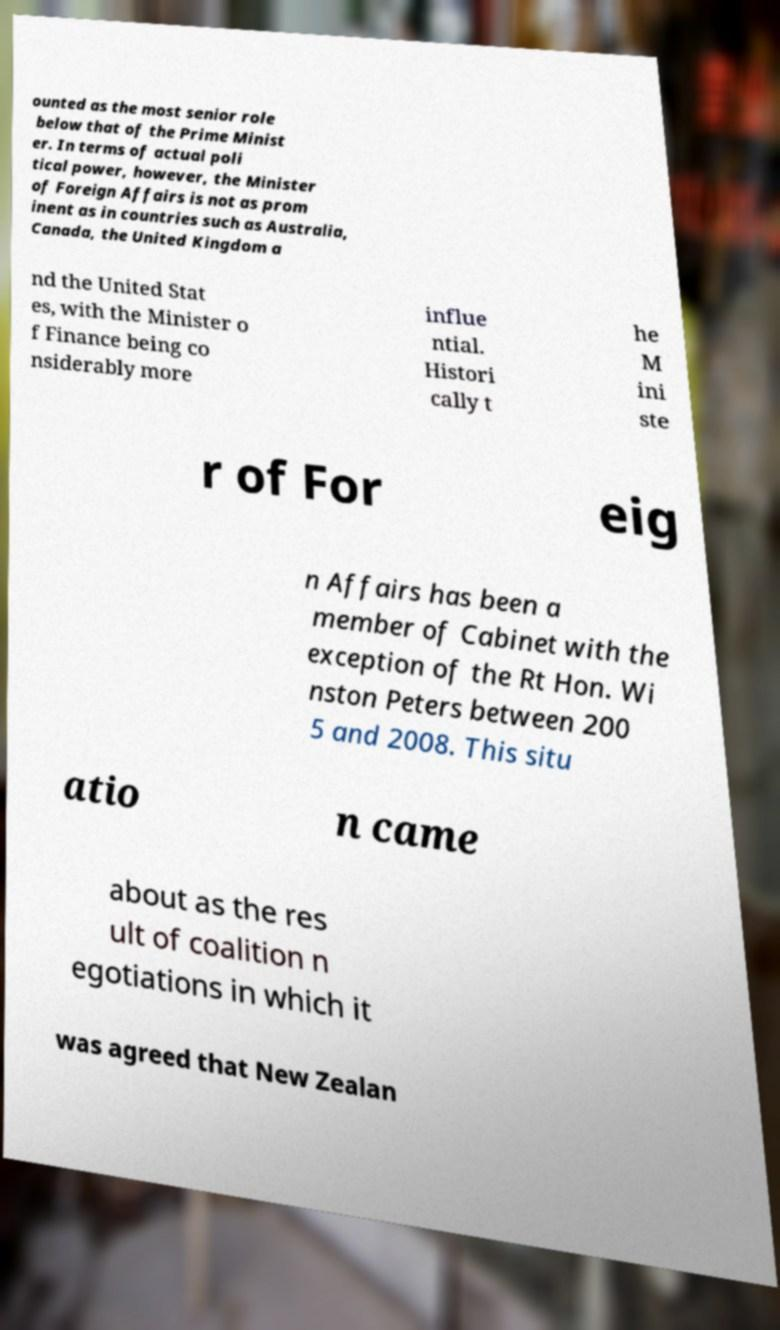For documentation purposes, I need the text within this image transcribed. Could you provide that? ounted as the most senior role below that of the Prime Minist er. In terms of actual poli tical power, however, the Minister of Foreign Affairs is not as prom inent as in countries such as Australia, Canada, the United Kingdom a nd the United Stat es, with the Minister o f Finance being co nsiderably more influe ntial. Histori cally t he M ini ste r of For eig n Affairs has been a member of Cabinet with the exception of the Rt Hon. Wi nston Peters between 200 5 and 2008. This situ atio n came about as the res ult of coalition n egotiations in which it was agreed that New Zealan 